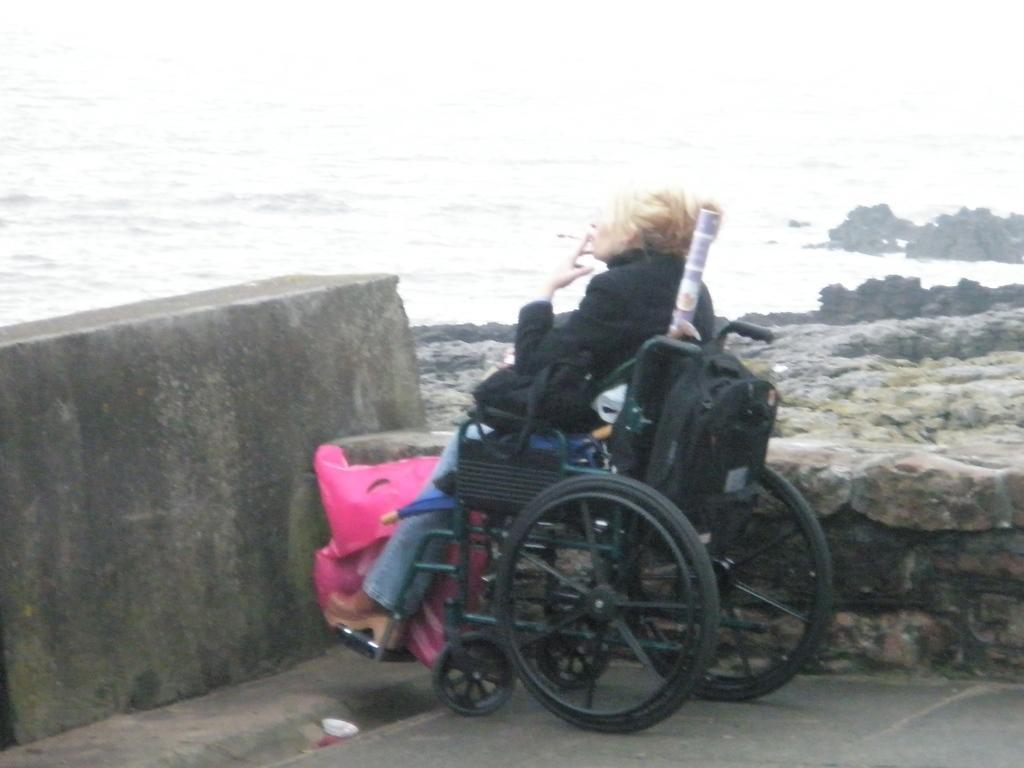Describe this image in one or two sentences. In this image, we can see a person is sitting on a wheelchair. Here we can see a pink color cover and wall. Background we can see a water and rocks. 